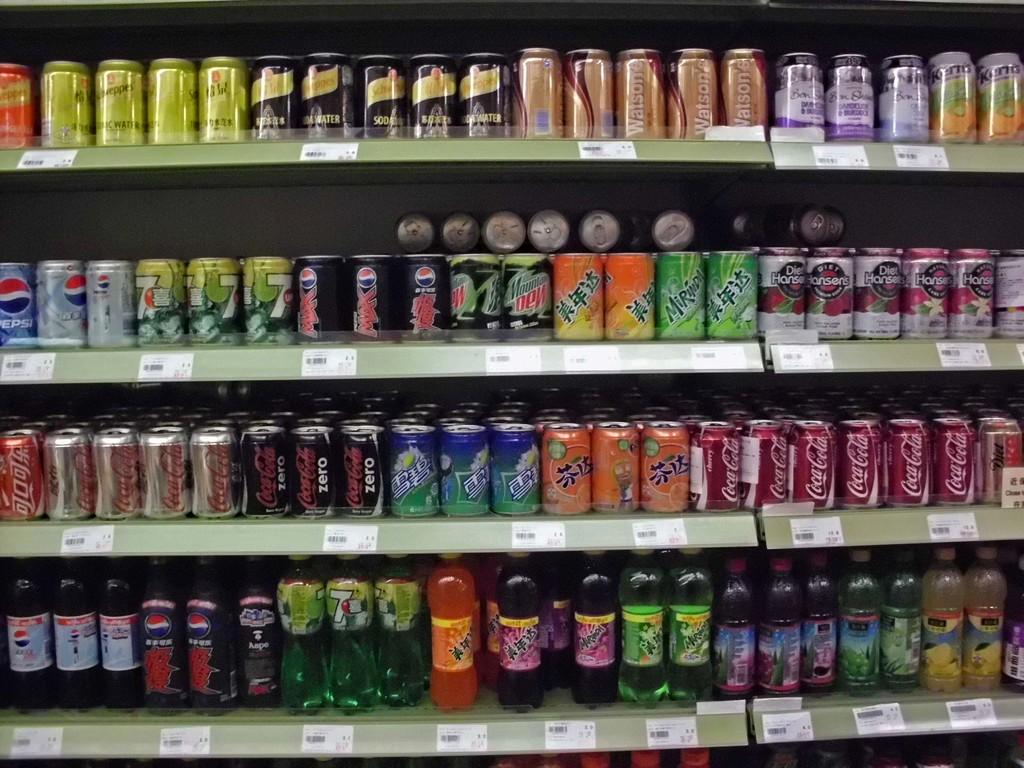What type of containers are visible in the image? There are tins in the image. What type of storage or display feature is present in the image? There are shelves in the image. What type of liquid containers are visible in the image? There are bottles in the image. What type of decorative items are visible in the image? There are posters in the image. What type of written material is visible in the image? There are papers in the image. What type of identification or pricing feature is visible on the items in the image? There are bar codes in the image. What type of veil can be seen covering the tins in the image? There is no veil present in the image; the tins are visible and not covered. What type of smell can be detected from the bottles in the image? The image is visual, and there is no information about smells provided. 